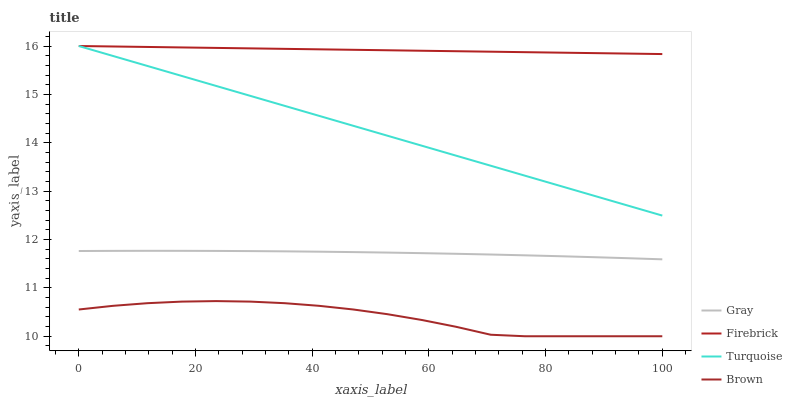Does Turquoise have the minimum area under the curve?
Answer yes or no. No. Does Turquoise have the maximum area under the curve?
Answer yes or no. No. Is Turquoise the smoothest?
Answer yes or no. No. Is Turquoise the roughest?
Answer yes or no. No. Does Turquoise have the lowest value?
Answer yes or no. No. Does Brown have the highest value?
Answer yes or no. No. Is Brown less than Firebrick?
Answer yes or no. Yes. Is Gray greater than Brown?
Answer yes or no. Yes. Does Brown intersect Firebrick?
Answer yes or no. No. 